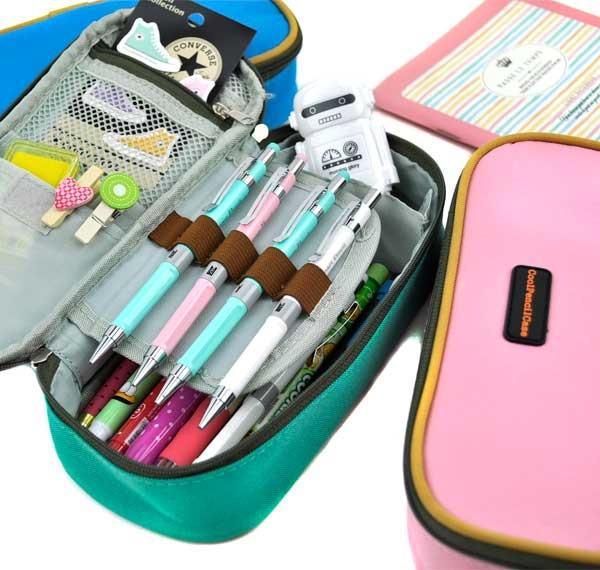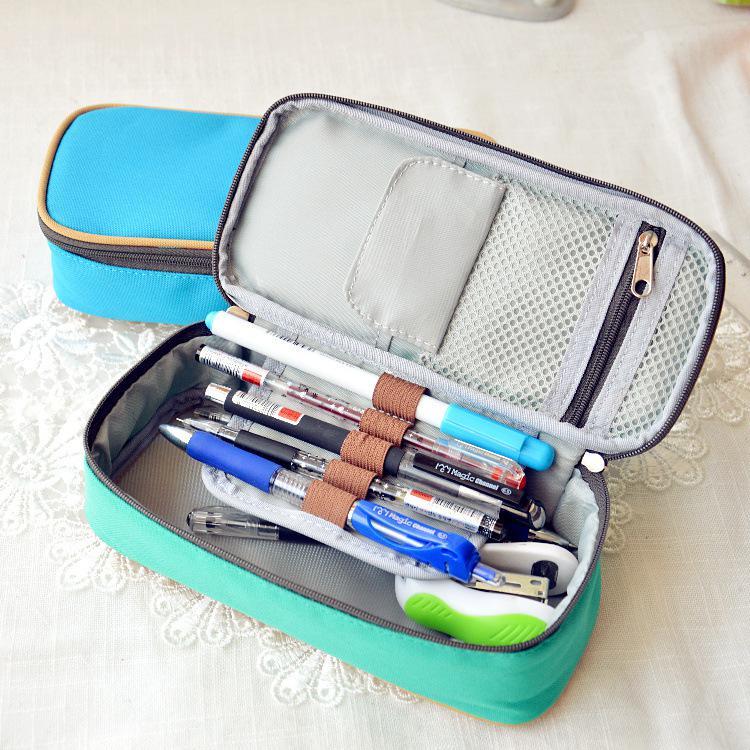The first image is the image on the left, the second image is the image on the right. Considering the images on both sides, is "Each image contains an open turquoise blue pencil box." valid? Answer yes or no. Yes. 